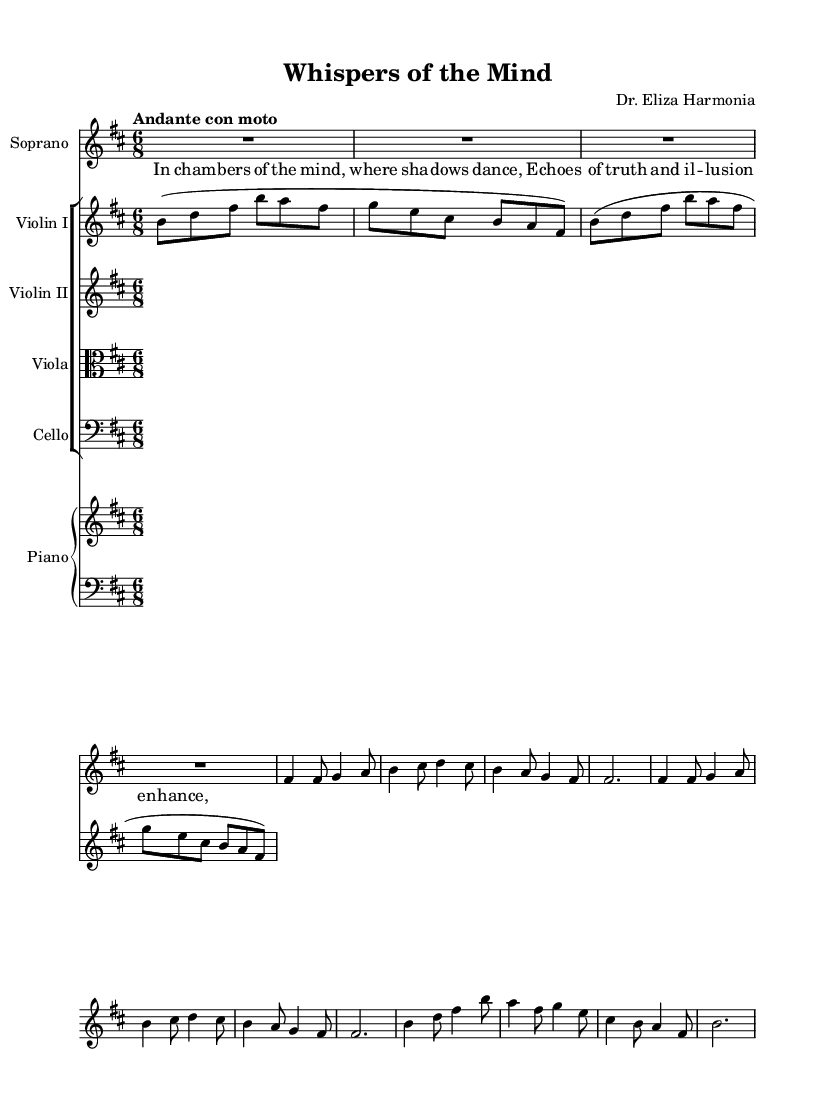What is the key signature of this music? The key signature is B minor, which is indicated by the presence of two sharps (F# and C#) in the key signature section at the beginning of the staff.
Answer: B minor What is the time signature of this music? The time signature is 6/8, which is shown at the beginning of the score with a '6' above a '8'. This indicates there are six eighth-note beats per measure.
Answer: 6/8 What is the tempo marking for this piece? The tempo marking is "Andante con moto," which indicates a moderate but slightly quicker pace. This is located directly beneath the clef and key signature at the beginning of the sheet music.
Answer: Andante con moto How many measures are in the chorus section? The chorus section consists of four measures, as seen by counting the bar lines while following the notes written in the soprano part that is associated with the chorus.
Answer: 4 measures What vocal range is indicated for the soprano part? The soprano part is written in a higher register starting from the note F# above middle C. The notes are primarily positioned within the clef's higher ranges, indicating the part is for soprano voice.
Answer: Soprano What type of ensemble is used in this composition? The ensemble consists of a string quartet along with a piano, as indicated by the four string parts and the piano staff that is incorporated in the score layout.
Answer: String quartet and piano 